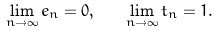Convert formula to latex. <formula><loc_0><loc_0><loc_500><loc_500>\lim _ { n \rightarrow \infty } e _ { n } = 0 , \quad \lim _ { n \rightarrow \infty } t _ { n } = 1 .</formula> 